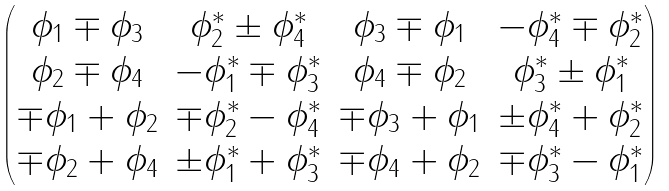<formula> <loc_0><loc_0><loc_500><loc_500>\begin{pmatrix} \phi _ { 1 } \mp \phi _ { 3 } & \phi ^ { \ast } _ { 2 } \pm \phi ^ { \ast } _ { 4 } & \phi _ { 3 } \mp \phi _ { 1 } & - \phi ^ { \ast } _ { 4 } \mp \phi ^ { \ast } _ { 2 } \\ \phi _ { 2 } \mp \phi _ { 4 } & - \phi ^ { \ast } _ { 1 } \mp \phi ^ { \ast } _ { 3 } & \phi _ { 4 } \mp \phi _ { 2 } & \phi ^ { \ast } _ { 3 } \pm \phi ^ { \ast } _ { 1 } \\ \mp \phi _ { 1 } + \phi _ { 2 } & \mp \phi ^ { \ast } _ { 2 } - \phi ^ { \ast } _ { 4 } & \mp \phi _ { 3 } + \phi _ { 1 } & \pm \phi ^ { \ast } _ { 4 } + \phi ^ { \ast } _ { 2 } \\ \mp \phi _ { 2 } + \phi _ { 4 } & \pm \phi ^ { \ast } _ { 1 } + \phi ^ { \ast } _ { 3 } & \mp \phi _ { 4 } + \phi _ { 2 } & \mp \phi ^ { \ast } _ { 3 } - \phi ^ { \ast } _ { 1 } \end{pmatrix}</formula> 